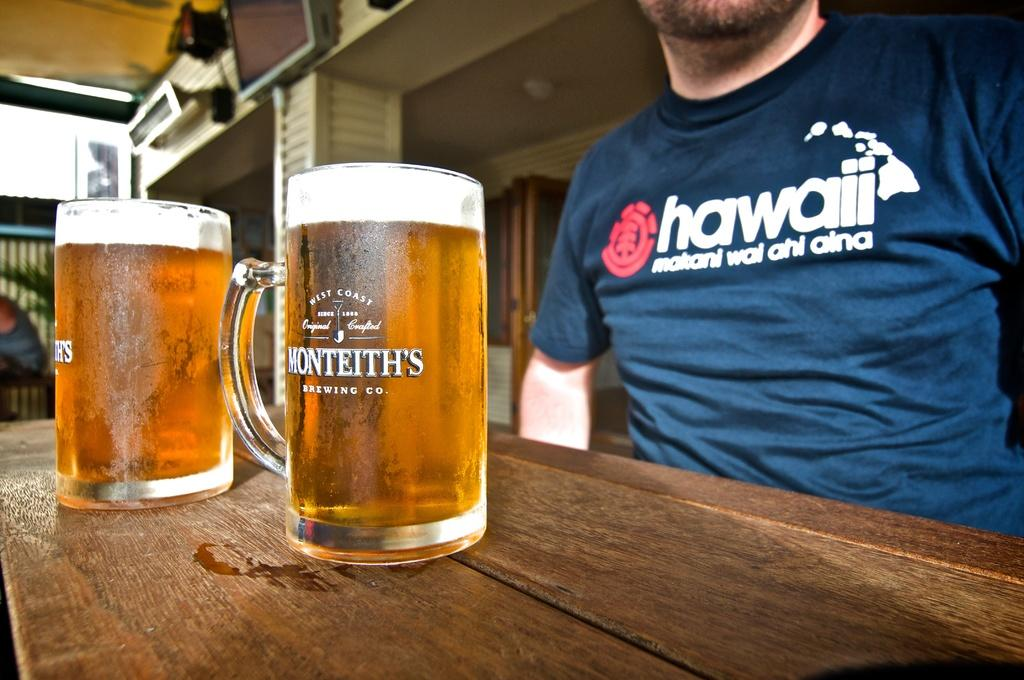<image>
Relay a brief, clear account of the picture shown. A man with a blue Hawaii shirt sitting behind a beer mug which states Monteith's 